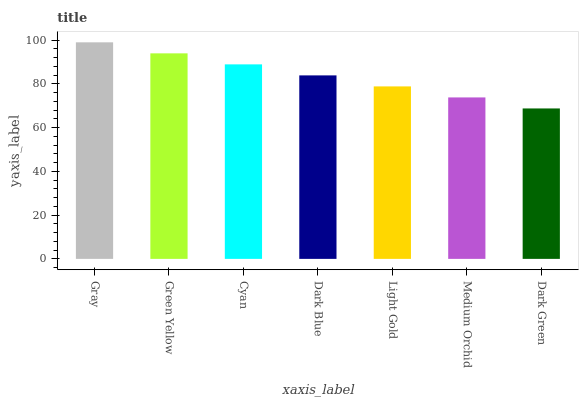Is Dark Green the minimum?
Answer yes or no. Yes. Is Gray the maximum?
Answer yes or no. Yes. Is Green Yellow the minimum?
Answer yes or no. No. Is Green Yellow the maximum?
Answer yes or no. No. Is Gray greater than Green Yellow?
Answer yes or no. Yes. Is Green Yellow less than Gray?
Answer yes or no. Yes. Is Green Yellow greater than Gray?
Answer yes or no. No. Is Gray less than Green Yellow?
Answer yes or no. No. Is Dark Blue the high median?
Answer yes or no. Yes. Is Dark Blue the low median?
Answer yes or no. Yes. Is Green Yellow the high median?
Answer yes or no. No. Is Light Gold the low median?
Answer yes or no. No. 